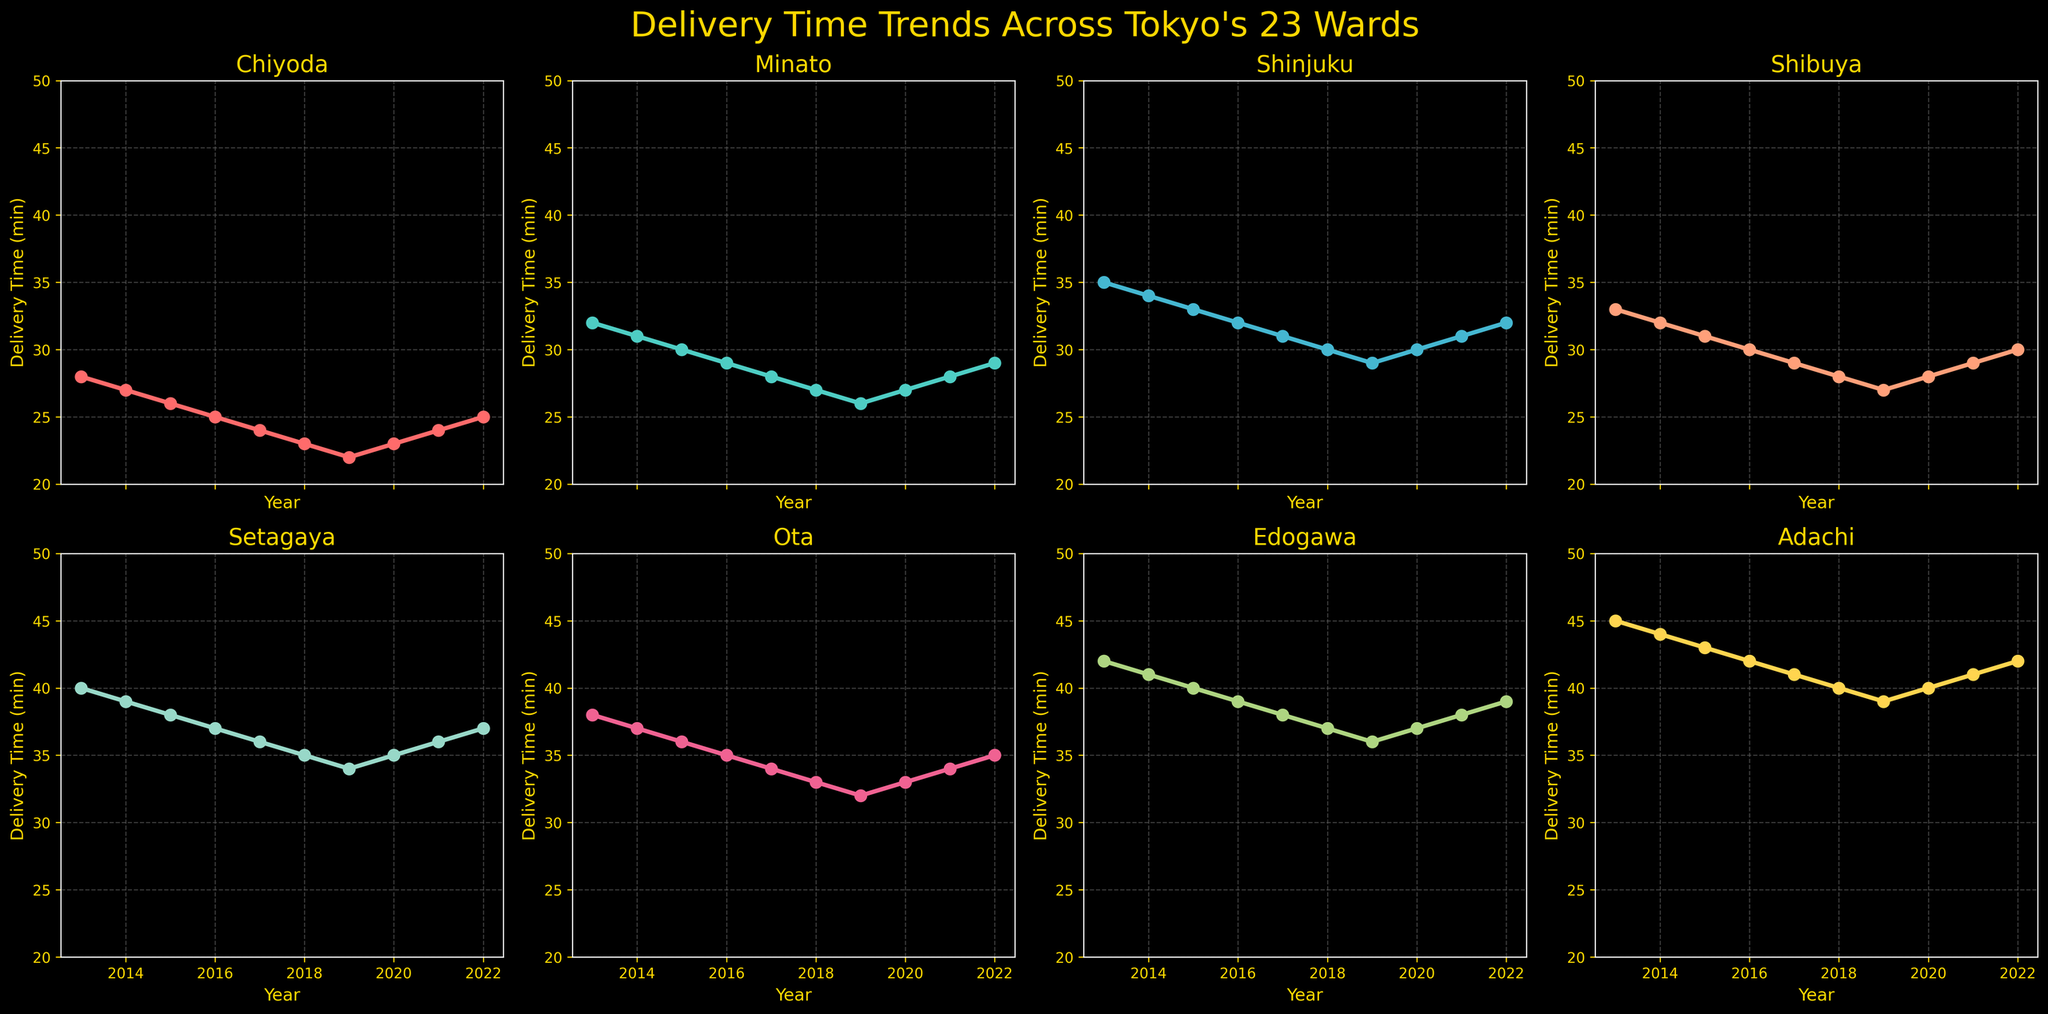What's the title of the figure? The title is displayed at the top center of the figure and reads: "Delivery Time Trends Across Tokyo's 23 Wards".
Answer: Delivery Time Trends Across Tokyo's 23 Wards How many wards are compared in the figure? There are subplots for each ward and counting the number of subplots gives the information. There are 8 wards compared in the figure.
Answer: 8 Which ward had the highest delivery time in 2013? The data shows different values for each ward in 2013. Edogawa has the highest delivery time among all wards in 2013.
Answer: Edogawa Has Minato's delivery time increased or decreased over the decade? By observing the trend of the line in the Minato subplot, it shows a general decline from 2013 to 2022, indicating a decrease in delivery time.
Answer: Decreased What is the general trend in delivery times for Shinjuku ward? By observing the Shinjuku subplot, the delivery time consistently decreased from 2013 to 2019 and then slightly increased again by 2022.
Answer: Decreasing then slight increase Which ward showed the smallest variability in delivery times over the decade? Analyzing the fluctuations in the lines, Chiyoda shows the smallest variability in delivery times (the most stable line).
Answer: Chiyoda Did any ward have the same delivery time in two different years? If yes, which ward and years? Observing each subplot, both Shibuya and Ota show that they had the same delivery time in 2018 and 2020 (28 and 33 minutes respectively).
Answer: Shibuya in 2018 and 2020, Ota in 2018 and 2020 What was the overall trend for delivery times across the wards from 2013 to 2019? Considering the displayed trends in each subplot, each ward shows a decrease in delivery times across these years, indicating an overall reduction trend for delivery times in this period.
Answer: Reduction trend Which two wards had the most similar delivery time trends? Comparing the patterns of the lines, the wards Ota and Edogawa show the most similar trends, as both lines decrease and then show a stable phase around the same years.
Answer: Ota and Edogawa 